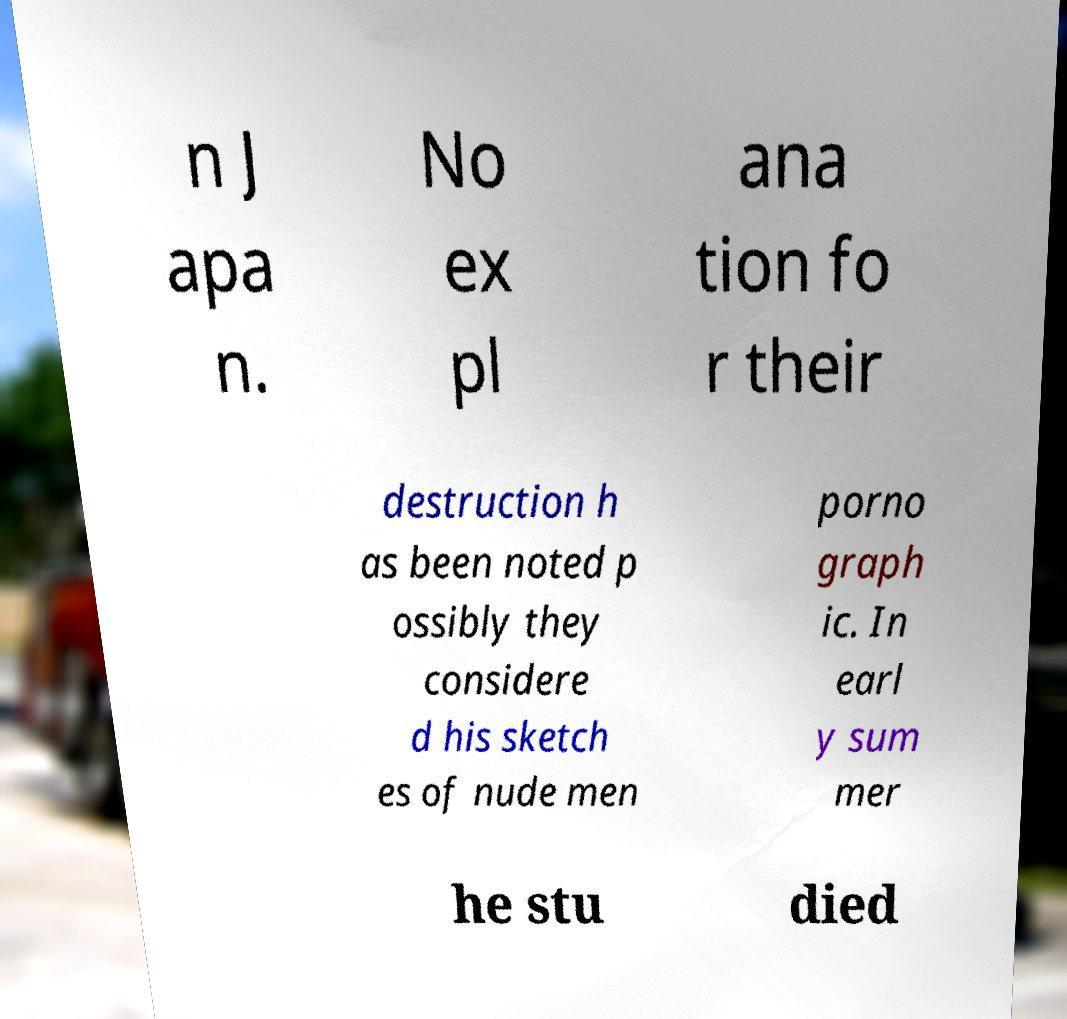What messages or text are displayed in this image? I need them in a readable, typed format. n J apa n. No ex pl ana tion fo r their destruction h as been noted p ossibly they considere d his sketch es of nude men porno graph ic. In earl y sum mer he stu died 